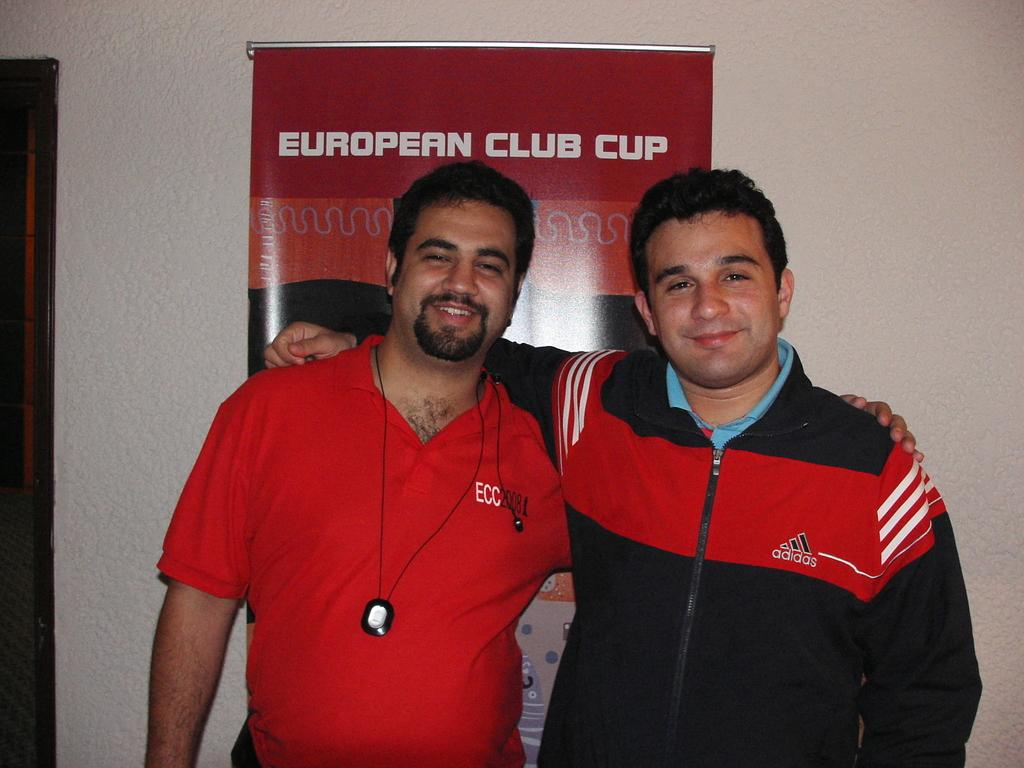Provide a one-sentence caption for the provided image. Two men involved in sports pose for a picture in front of a red poster saying European Club Cup. 